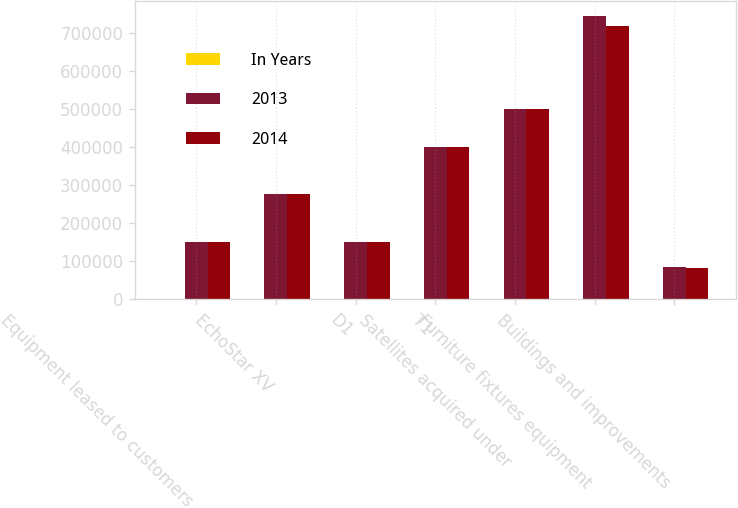Convert chart. <chart><loc_0><loc_0><loc_500><loc_500><stacked_bar_chart><ecel><fcel>Equipment leased to customers<fcel>EchoStar XV<fcel>D1<fcel>T1<fcel>Satellites acquired under<fcel>Furniture fixtures equipment<fcel>Buildings and improvements<nl><fcel>In Years<fcel>25<fcel>15<fcel>15<fcel>15<fcel>1015<fcel>110<fcel>140<nl><fcel>2013<fcel>150000<fcel>277658<fcel>150000<fcel>401721<fcel>499819<fcel>747139<fcel>85509<nl><fcel>2014<fcel>150000<fcel>277658<fcel>150000<fcel>401721<fcel>499819<fcel>720570<fcel>83531<nl></chart> 